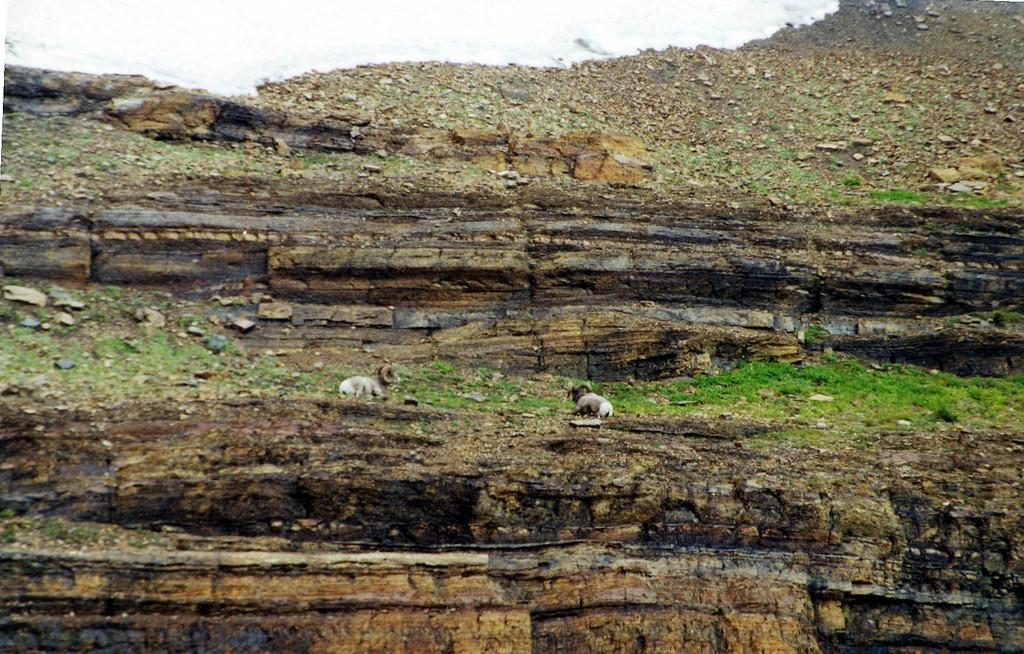What type of geological formation is in the image? There is a rock mountain in the image. What animals can be seen in the image? Two sheep are present in the image. What are the sheep doing in the image? The sheep are sitting and eating grass. Where is the lift located in the image? There is no lift present in the image; it features a rock mountain and two sheep. What type of tin can be seen in the image? There is no tin present in the image. 